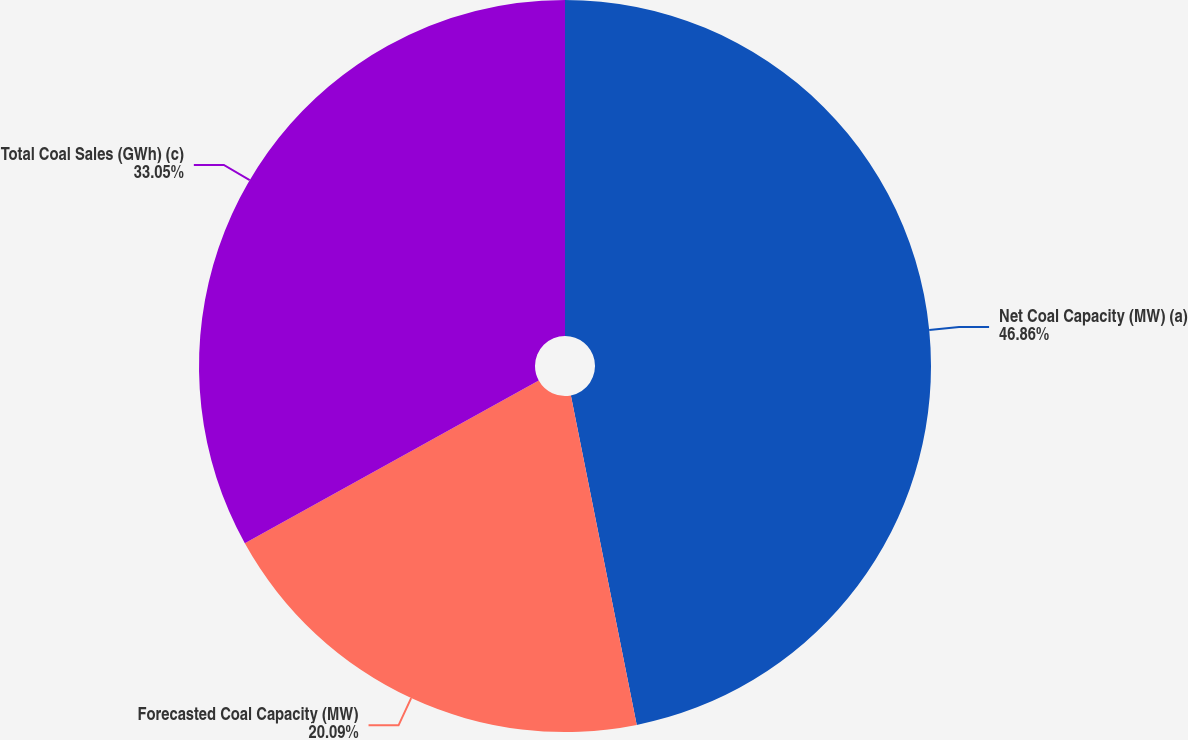Convert chart to OTSL. <chart><loc_0><loc_0><loc_500><loc_500><pie_chart><fcel>Net Coal Capacity (MW) (a)<fcel>Forecasted Coal Capacity (MW)<fcel>Total Coal Sales (GWh) (c)<nl><fcel>46.86%<fcel>20.09%<fcel>33.05%<nl></chart> 